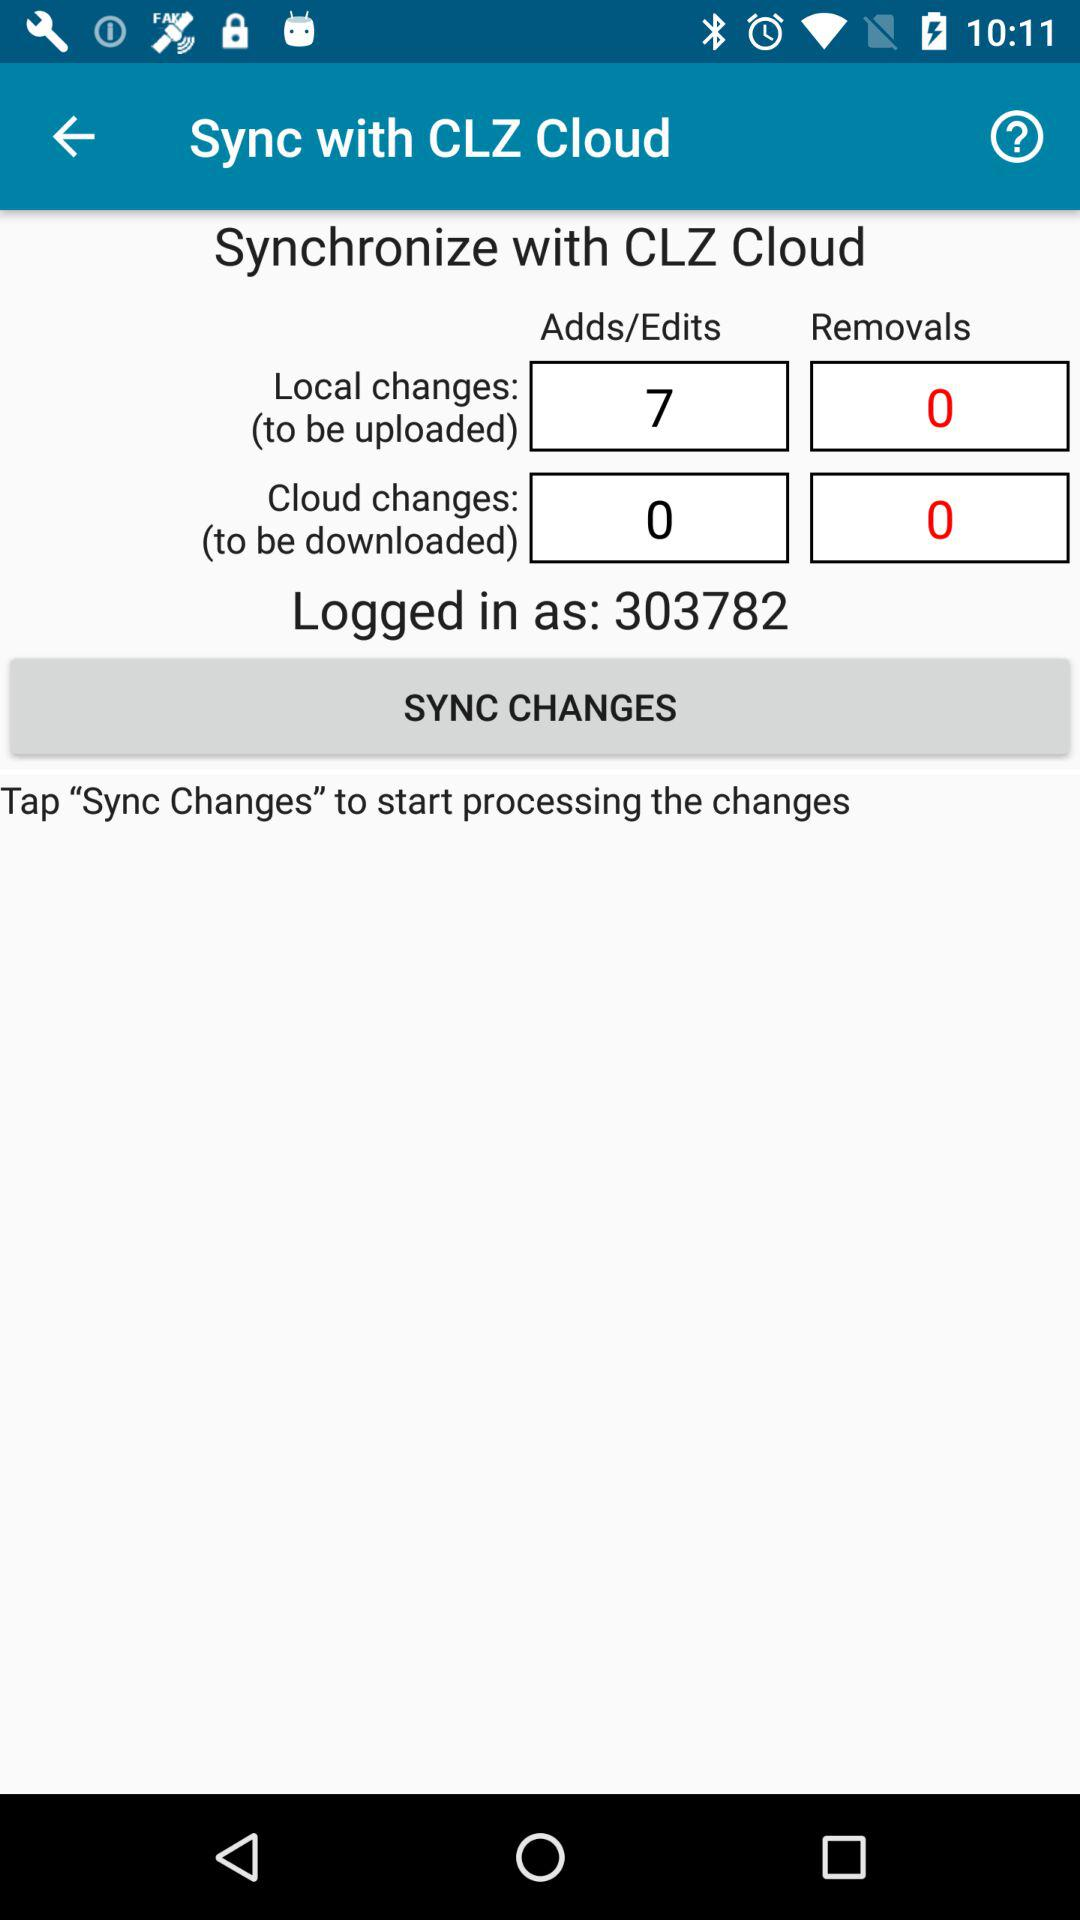How many more additions and edits are there than removals? After assessing the synchronization data, it's clear that there are 7 more additions and edits than removals. Specifically, there are 7 additions/edits pending to be uploaded and 0 removals, indicating a complete absence of deletions in this sync session. 